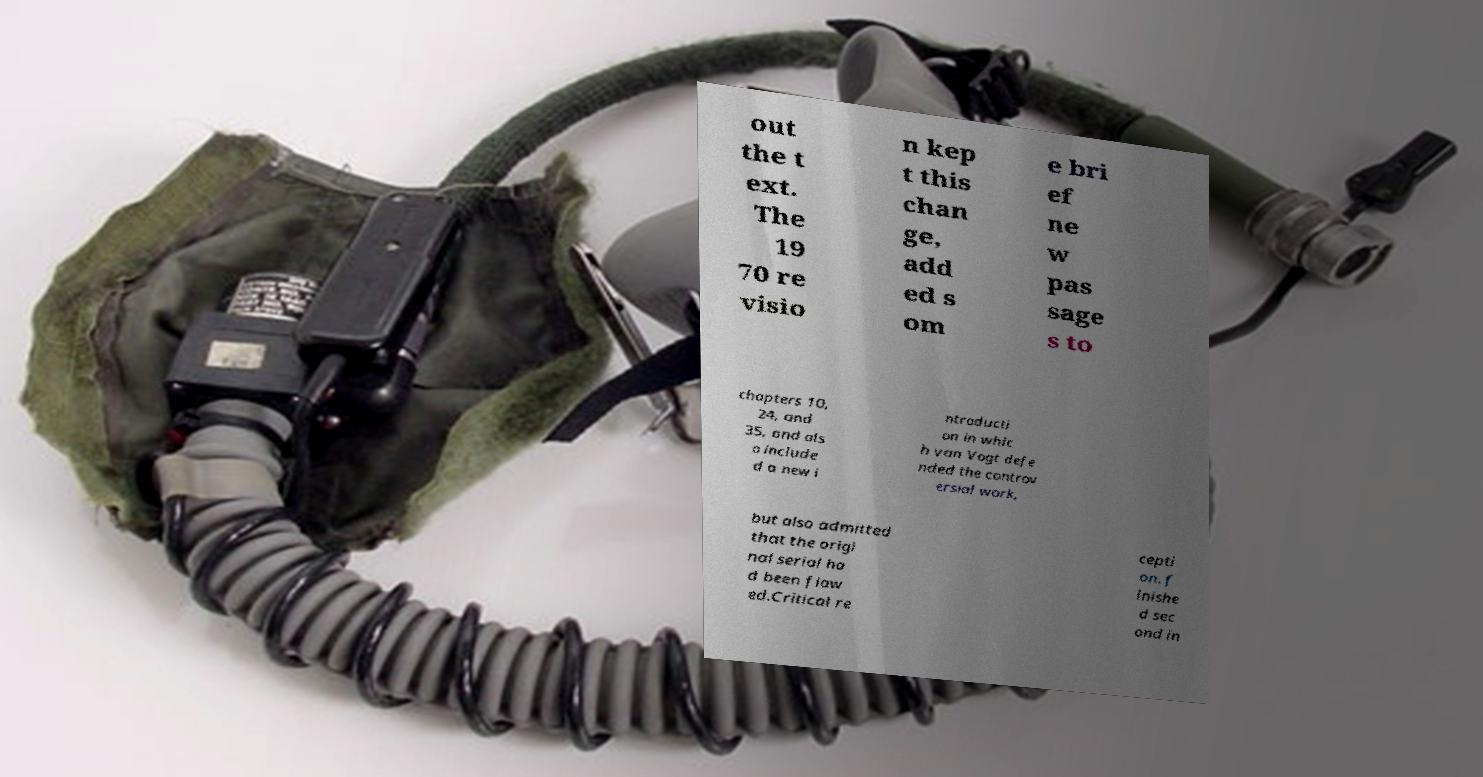For documentation purposes, I need the text within this image transcribed. Could you provide that? out the t ext. The 19 70 re visio n kep t this chan ge, add ed s om e bri ef ne w pas sage s to chapters 10, 24, and 35, and als o include d a new i ntroducti on in whic h van Vogt defe nded the controv ersial work, but also admitted that the origi nal serial ha d been flaw ed.Critical re cepti on. f inishe d sec ond in 